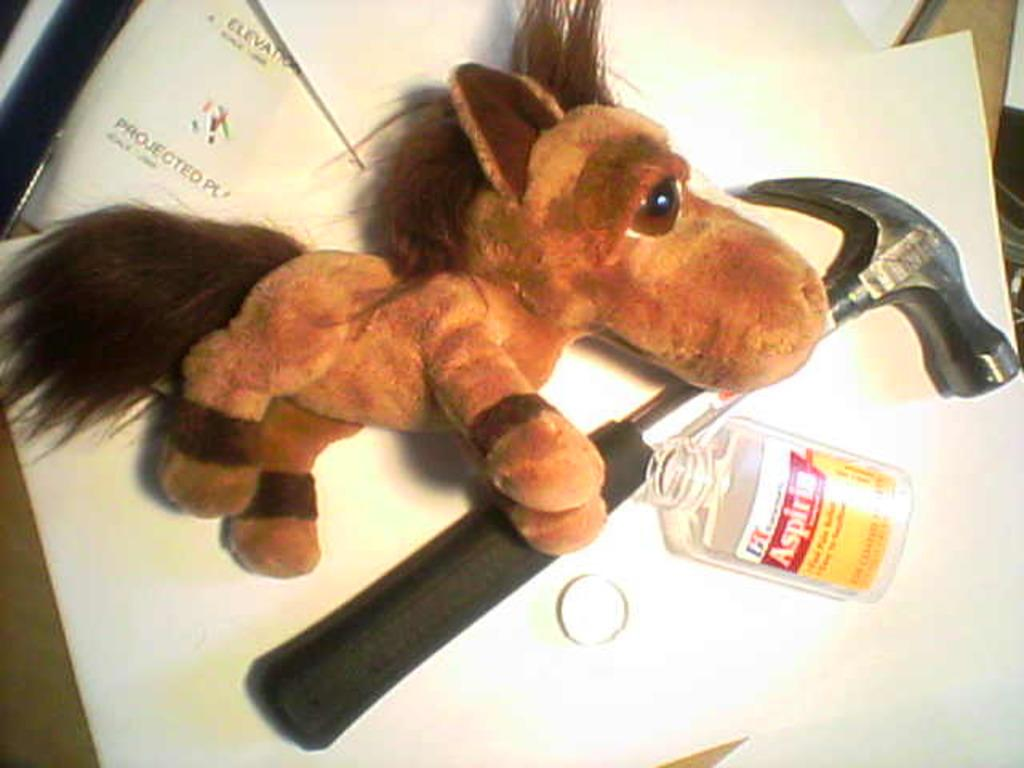What type of toy is present in the image? There is a horse doll in the image. What color is the horse doll? The horse doll is brown in color. What tool is visible in the image? There is a nail puller in the image. What other object can be seen in the image? There is a bottle in the image. Can you see the ocean in the image? No, the ocean is not present in the image. Is there any indication of an order or payment in the image? No, there is no mention of an order or payment in the image. 